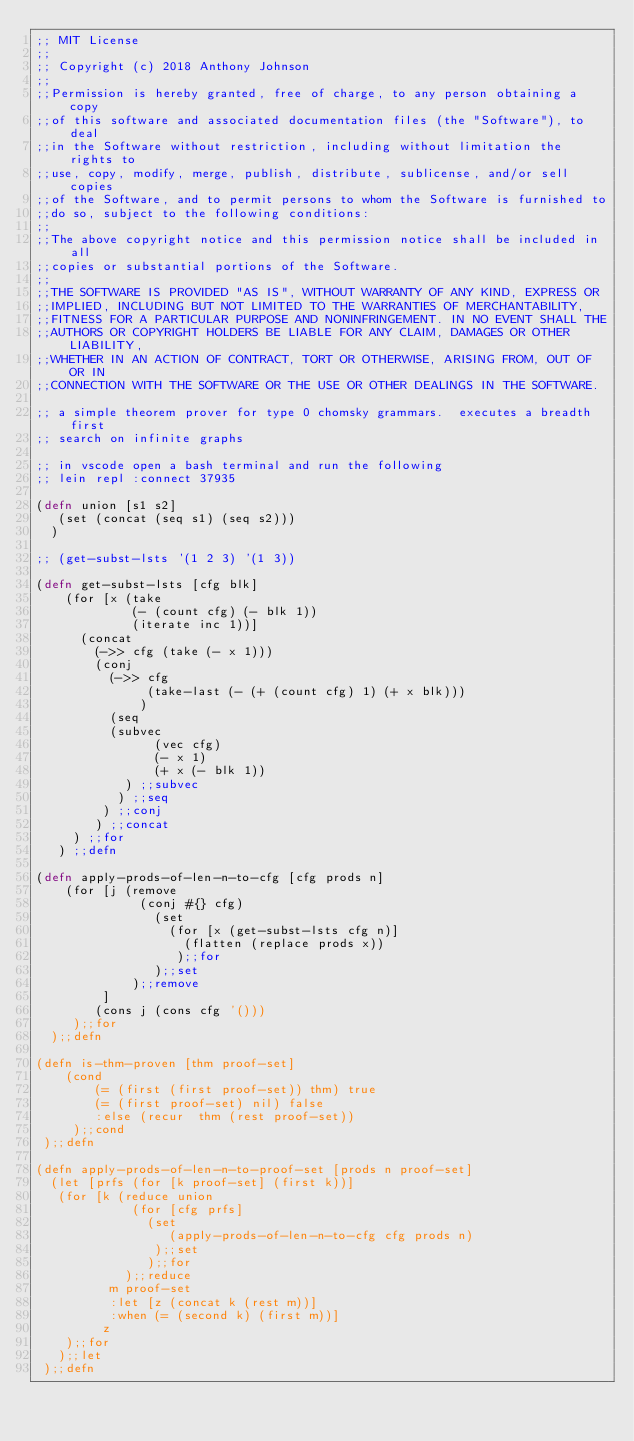<code> <loc_0><loc_0><loc_500><loc_500><_Clojure_>;; MIT License
;;
;; Copyright (c) 2018 Anthony Johnson
;;
;;Permission is hereby granted, free of charge, to any person obtaining a copy 
;;of this software and associated documentation files (the "Software"), to deal 
;;in the Software without restriction, including without limitation the rights to 
;;use, copy, modify, merge, publish, distribute, sublicense, and/or sell copies 
;;of the Software, and to permit persons to whom the Software is furnished to 
;;do so, subject to the following conditions:
;;
;;The above copyright notice and this permission notice shall be included in all 
;;copies or substantial portions of the Software.
;;
;;THE SOFTWARE IS PROVIDED "AS IS", WITHOUT WARRANTY OF ANY KIND, EXPRESS OR 
;;IMPLIED, INCLUDING BUT NOT LIMITED TO THE WARRANTIES OF MERCHANTABILITY, 
;;FITNESS FOR A PARTICULAR PURPOSE AND NONINFRINGEMENT. IN NO EVENT SHALL THE 
;;AUTHORS OR COPYRIGHT HOLDERS BE LIABLE FOR ANY CLAIM, DAMAGES OR OTHER LIABILITY, 
;;WHETHER IN AN ACTION OF CONTRACT, TORT OR OTHERWISE, ARISING FROM, OUT OF OR IN 
;;CONNECTION WITH THE SOFTWARE OR THE USE OR OTHER DEALINGS IN THE SOFTWARE.

;; a simple theorem prover for type 0 chomsky grammars.  executes a breadth first
;; search on infinite graphs

;; in vscode open a bash terminal and run the following
;; lein repl :connect 37935

(defn union [s1 s2]
   (set (concat (seq s1) (seq s2)))
  )

;; (get-subst-lsts '(1 2 3) '(1 3))

(defn get-subst-lsts [cfg blk]
    (for [x (take
             (- (count cfg) (- blk 1))
             (iterate inc 1))]
      (concat
        (->> cfg (take (- x 1)))
        (conj
          (->> cfg
               (take-last (- (+ (count cfg) 1) (+ x blk)))
              )
          (seq
          (subvec
                (vec cfg)
                (- x 1)
                (+ x (- blk 1))
            ) ;;subvec
           ) ;;seq
         ) ;;conj
        ) ;;concat
     ) ;;for
   ) ;;defn

(defn apply-prods-of-len-n-to-cfg [cfg prods n]
    (for [j (remove
              (conj #{} cfg)
                (set
                  (for [x (get-subst-lsts cfg n)]
                    (flatten (replace prods x))
                   );;for
                );;set
             );;remove
         ]
        (cons j (cons cfg '()))
     );;for
  );;defn

(defn is-thm-proven [thm proof-set]
    (cond
        (= (first (first proof-set)) thm) true
        (= (first proof-set) nil) false
        :else (recur  thm (rest proof-set))
     );;cond
 );;defn

(defn apply-prods-of-len-n-to-proof-set [prods n proof-set]
  (let [prfs (for [k proof-set] (first k))]
   (for [k (reduce union
             (for [cfg prfs]
               (set
                  (apply-prods-of-len-n-to-cfg cfg prods n)
                );;set
               );;for
            );;reduce
          m proof-set
          :let [z (concat k (rest m))]
          :when (= (second k) (first m))]
         z
    );;for
   );;let
 );;defn

</code> 